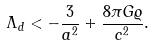<formula> <loc_0><loc_0><loc_500><loc_500>\Lambda _ { d } < - \frac { 3 } { a ^ { 2 } } + \frac { 8 \pi G \varrho } { c ^ { 2 } } .</formula> 